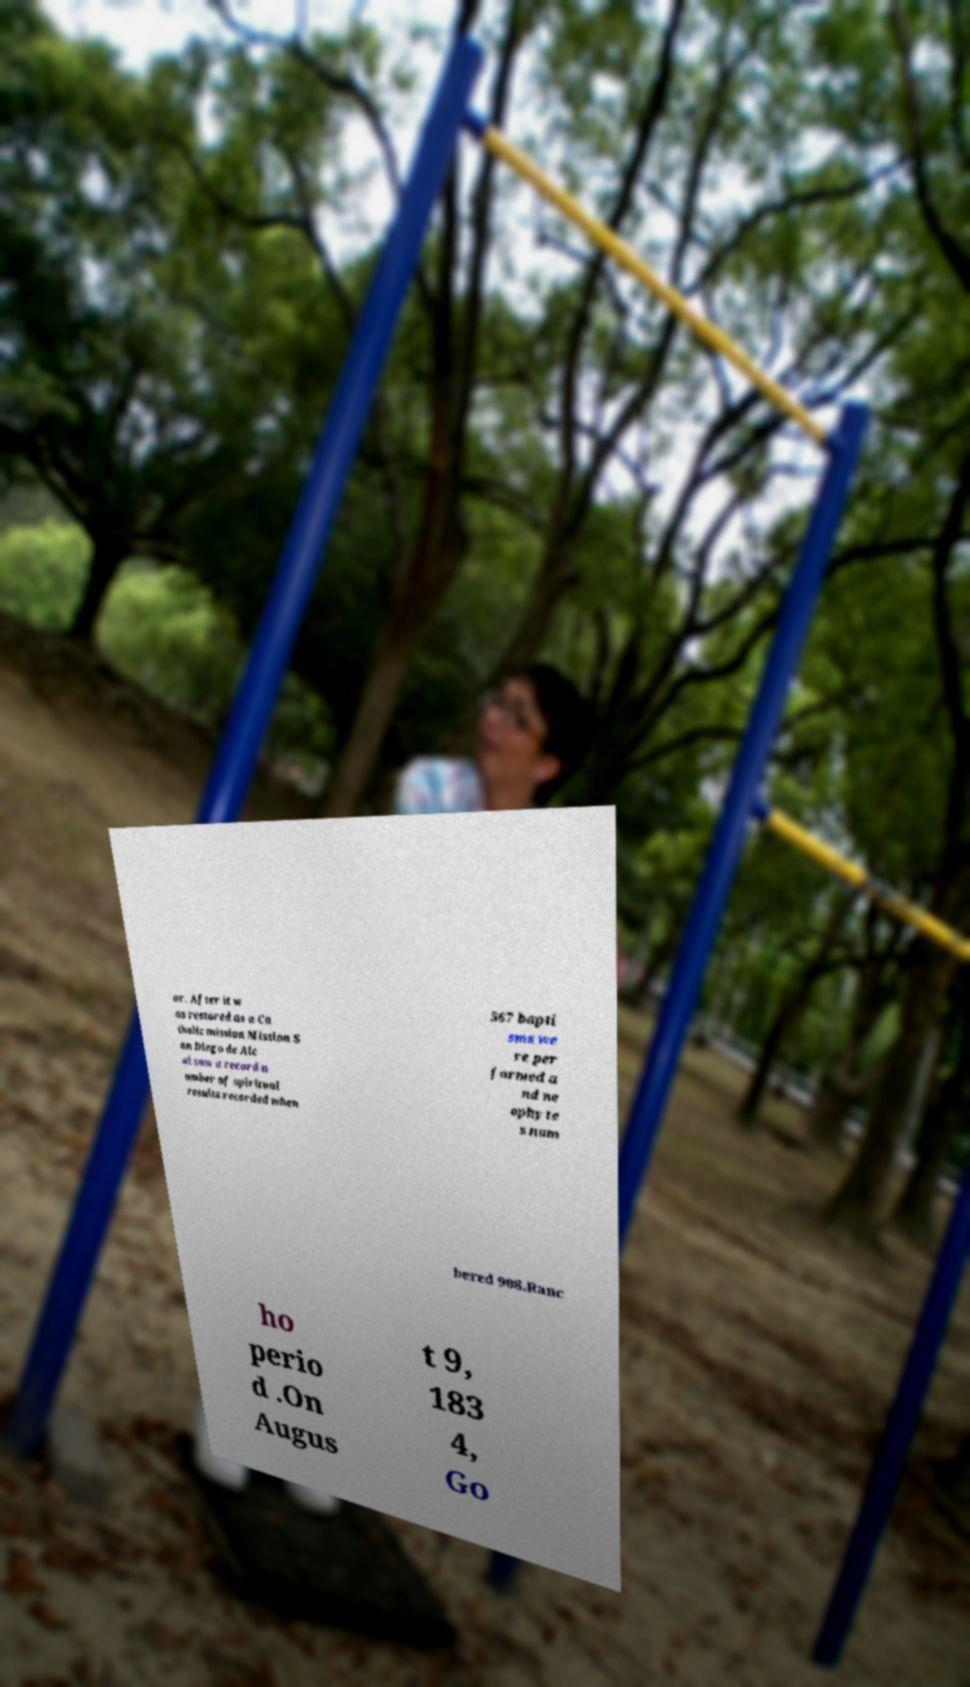For documentation purposes, I need the text within this image transcribed. Could you provide that? ar. After it w as restored as a Ca tholic mission Mission S an Diego de Alc al saw a record n umber of spiritual results recorded when 567 bapti sms we re per formed a nd ne ophyte s num bered 908.Ranc ho perio d .On Augus t 9, 183 4, Go 